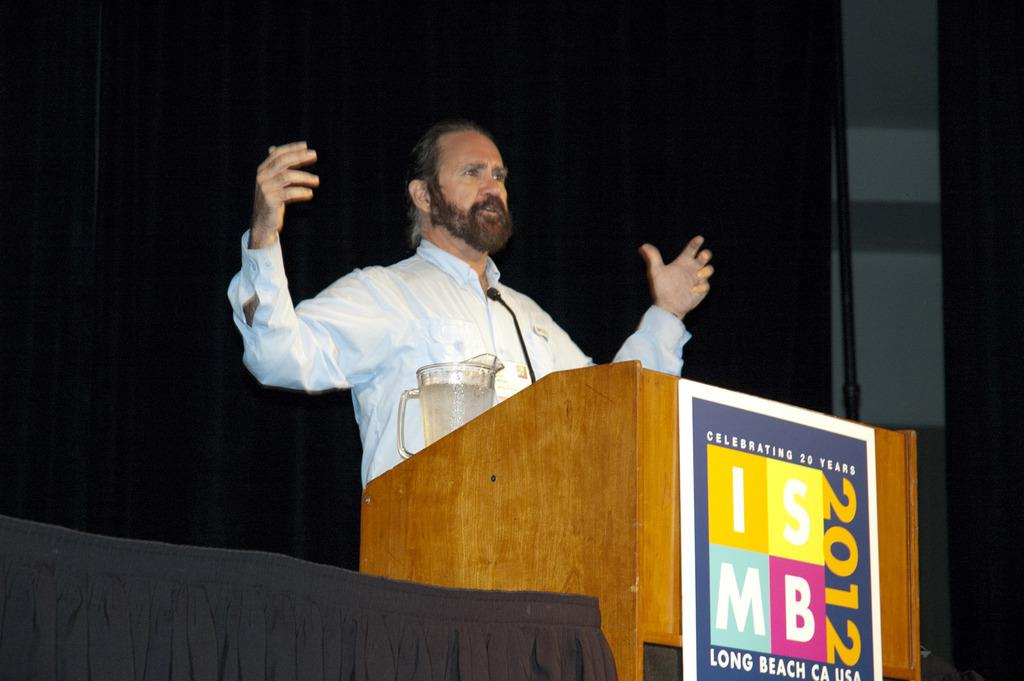<image>
Offer a succinct explanation of the picture presented. ISMB 2012 celebrated 20 years in Long Beach, California. 